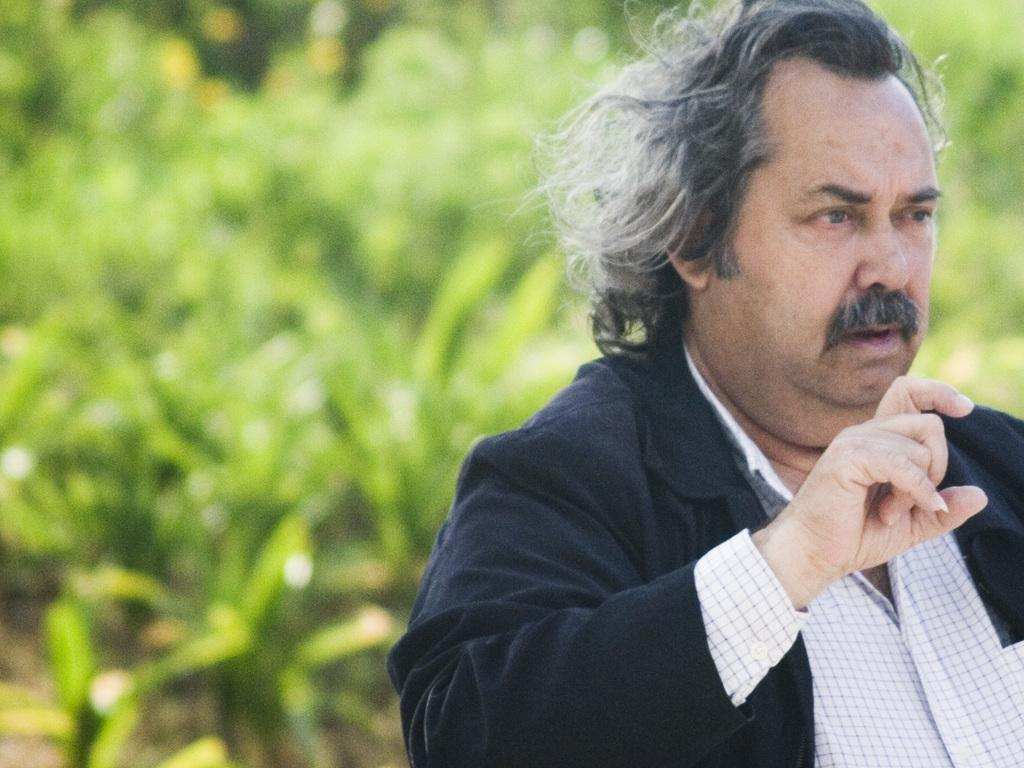Who is present in the image? There is a man in the image. What is the man wearing on his upper body? The man is wearing a black jacket and a white and black checks shirt. What color is the background of the image? The background of the image is green. What type of form is the man filling out in the image? There is no form present in the image; the man is simply standing there. What activity is the man participating in during the image? The image does not show the man participating in any specific activity. 